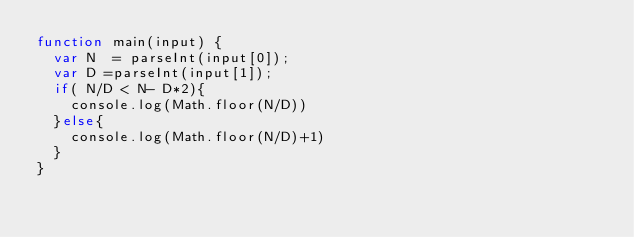<code> <loc_0><loc_0><loc_500><loc_500><_JavaScript_>function main(input) {
  var N  = parseInt(input[0]);
  var D =parseInt(input[1]);
  if( N/D < N- D*2){
    console.log(Math.floor(N/D))
  }else{
    console.log(Math.floor(N/D)+1)
  }
}</code> 